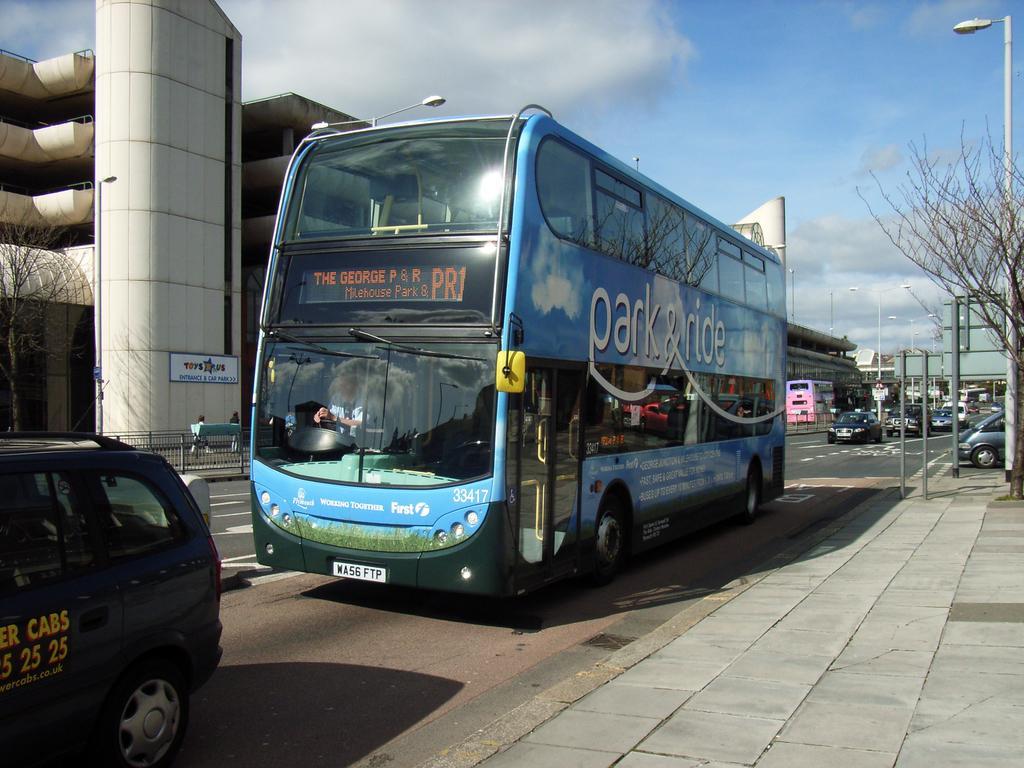How would you summarize this image in a sentence or two? In this image we can see the vehicles on the road. We can also see the buildings, trees, light poles, boards, barrier and also the path. We can also see the people walking. In the background we can see the sky with some clouds. 